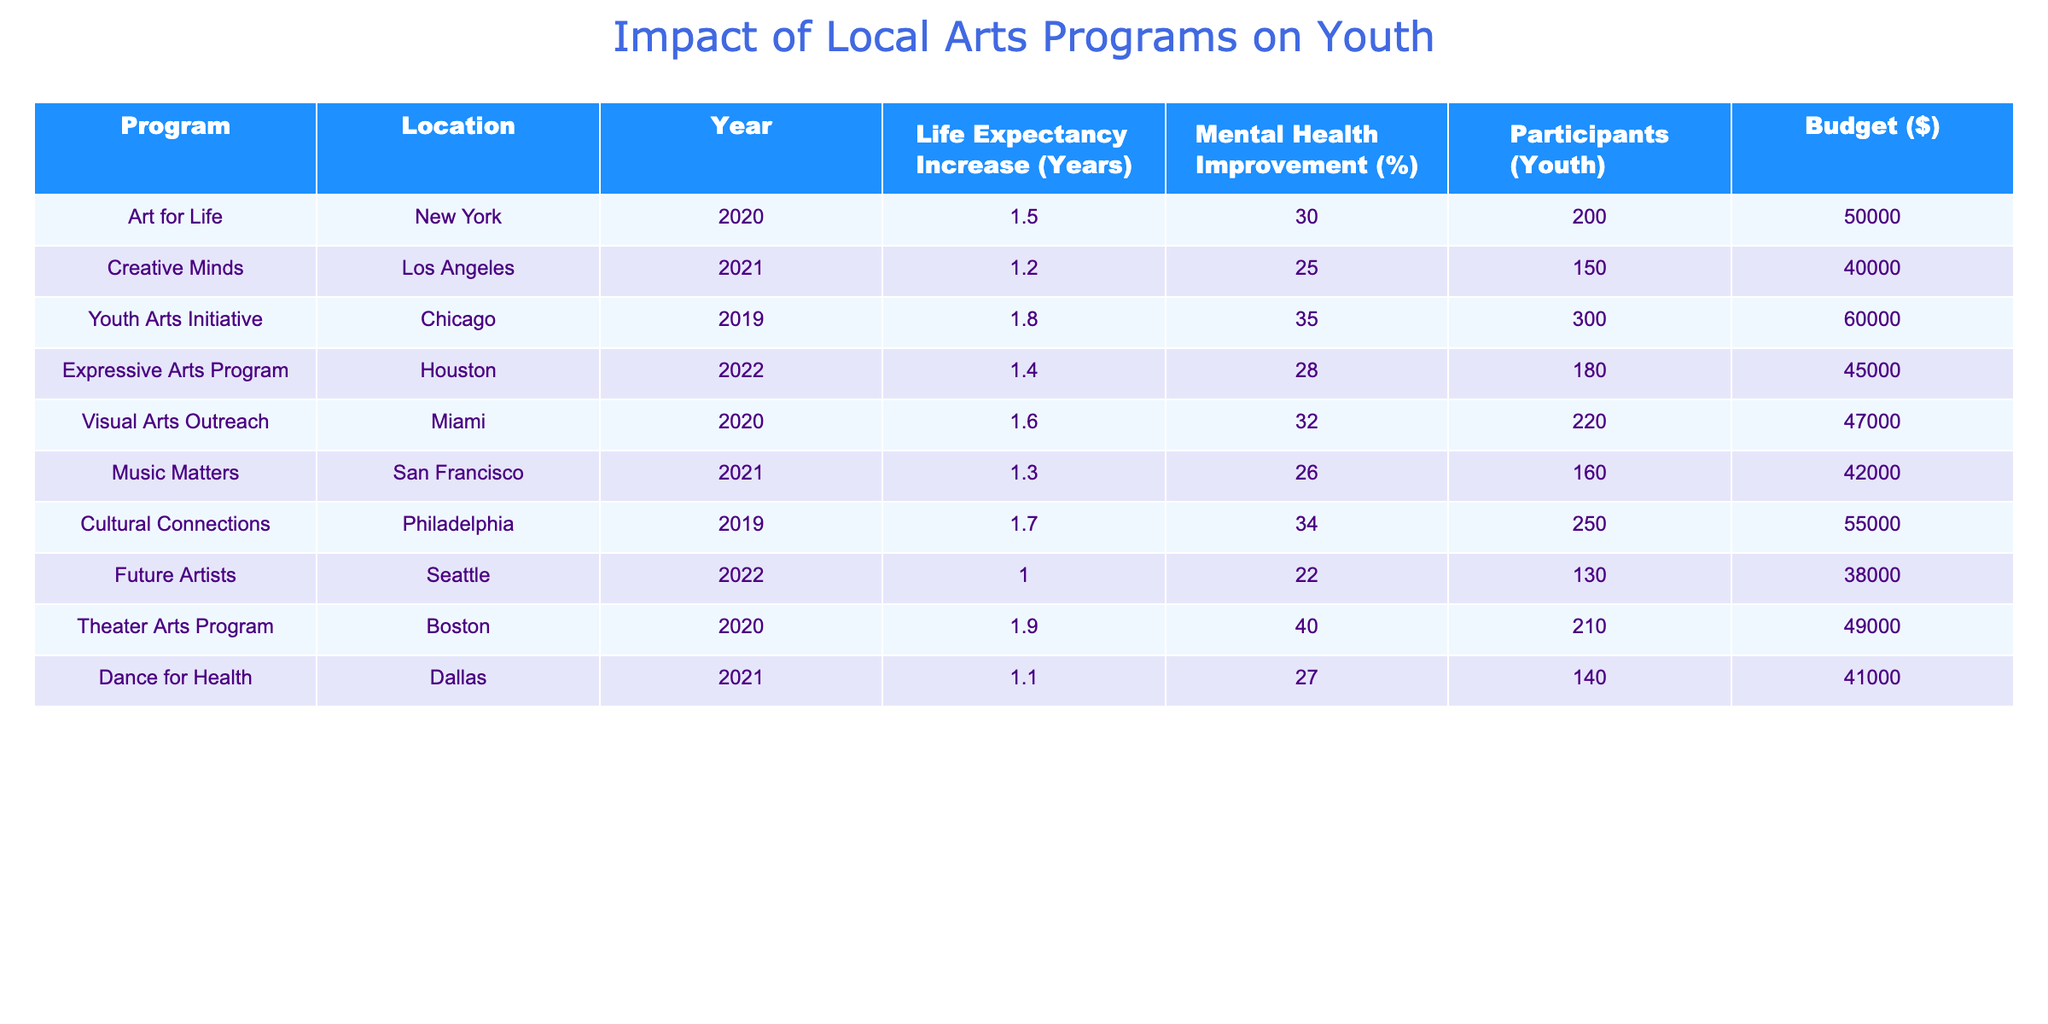What program had the highest life expectancy increase? Looking through the table, the program "Theater Arts Program" in Boston shows a life expectancy increase of 1.9 years, which is higher than any other program listed.
Answer: Theater Arts Program What is the total budget for the programs held in 2021? The programs in 2021 are "Creative Minds" ($40,000), "Music Matters" ($42,000), and "Dance for Health" ($41,000). Summing these gives a total of $40,000 + $42,000 + $41,000 = $123,000.
Answer: 123000 Which program had a mental health improvement percentage greater than 30%? By scanning the Mental Health Improvement column, the programs with percentages greater than 30% are "Art for Life" (30%), "Youth Arts Initiative" (35%), "Cultural Connections" (34%), and "Theater Arts Program" (40%).
Answer: Art for Life, Youth Arts Initiative, Cultural Connections, Theater Arts Program Is the average life expectancy increase of programs in New York greater than 1.5 years? The only program from New York is "Art for Life," which has a life expectancy increase of 1.5 years. Since there are no other programs in New York, the average is also 1.5 years. Therefore, the statement is false.
Answer: No What is the median mental health improvement percentage among the programs? To find the median, we first list the Mental Health Improvement percentages in ascending order: 22, 25, 26, 27, 28, 30, 32, 34, 35, 40. The middle values are 28 and 30, making the median (28 + 30) / 2 = 29.
Answer: 29 Which location had the lowest number of participants? The program "Future Artists" in Seattle had the lowest number of participants, with only 130 youths involved.
Answer: Seattle How many more participants were involved in "Youth Arts Initiative" compared to "Future Artists"? The number of participants in "Youth Arts Initiative" is 300, while "Future Artists" had 130 participants. The difference is 300 - 130 = 170 participants.
Answer: 170 Is there any program with a budget less than $40,000? By reviewing the budget amounts, all listed programs have budgets ranging from $38,000 to $60,000, therefore, there are no programs with budgets under $40,000.
Answer: No 